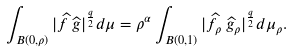Convert formula to latex. <formula><loc_0><loc_0><loc_500><loc_500>\int _ { B ( 0 , \rho ) } | \widehat { f } \, \widehat { g } | ^ { \frac { q } { 2 } } d \mu = \rho ^ { \alpha } \int _ { B ( 0 , 1 ) } | \widehat { f } _ { \rho } \, \widehat { g } _ { \rho } | ^ { \frac { q } { 2 } } d \mu _ { \rho } .</formula> 